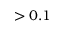<formula> <loc_0><loc_0><loc_500><loc_500>> 0 . 1</formula> 